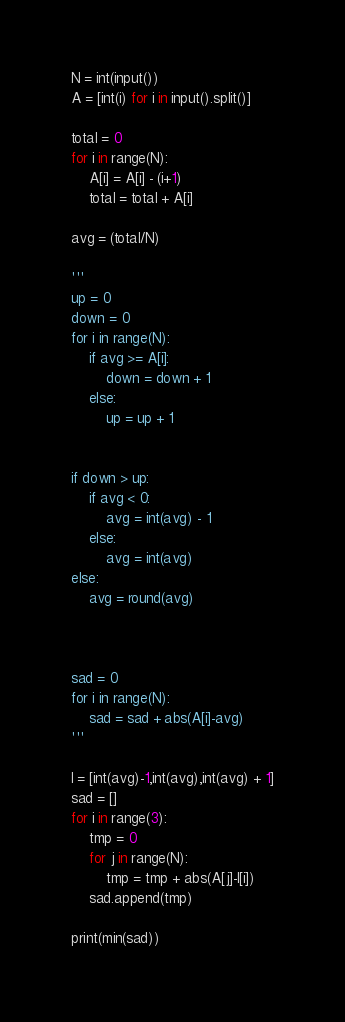Convert code to text. <code><loc_0><loc_0><loc_500><loc_500><_Python_>N = int(input())
A = [int(i) for i in input().split()]

total = 0
for i in range(N):
    A[i] = A[i] - (i+1)
    total = total + A[i]

avg = (total/N)

'''
up = 0
down = 0
for i in range(N):
    if avg >= A[i]:
        down = down + 1
    else:
        up = up + 1


if down > up:
    if avg < 0:
        avg = int(avg) - 1
    else:
        avg = int(avg)
else:
    avg = round(avg)



sad = 0
for i in range(N):
    sad = sad + abs(A[i]-avg)
'''

l = [int(avg)-1,int(avg),int(avg) + 1]
sad = []
for i in range(3):
    tmp = 0
    for j in range(N):
        tmp = tmp + abs(A[j]-l[i])
    sad.append(tmp)
    
print(min(sad))</code> 